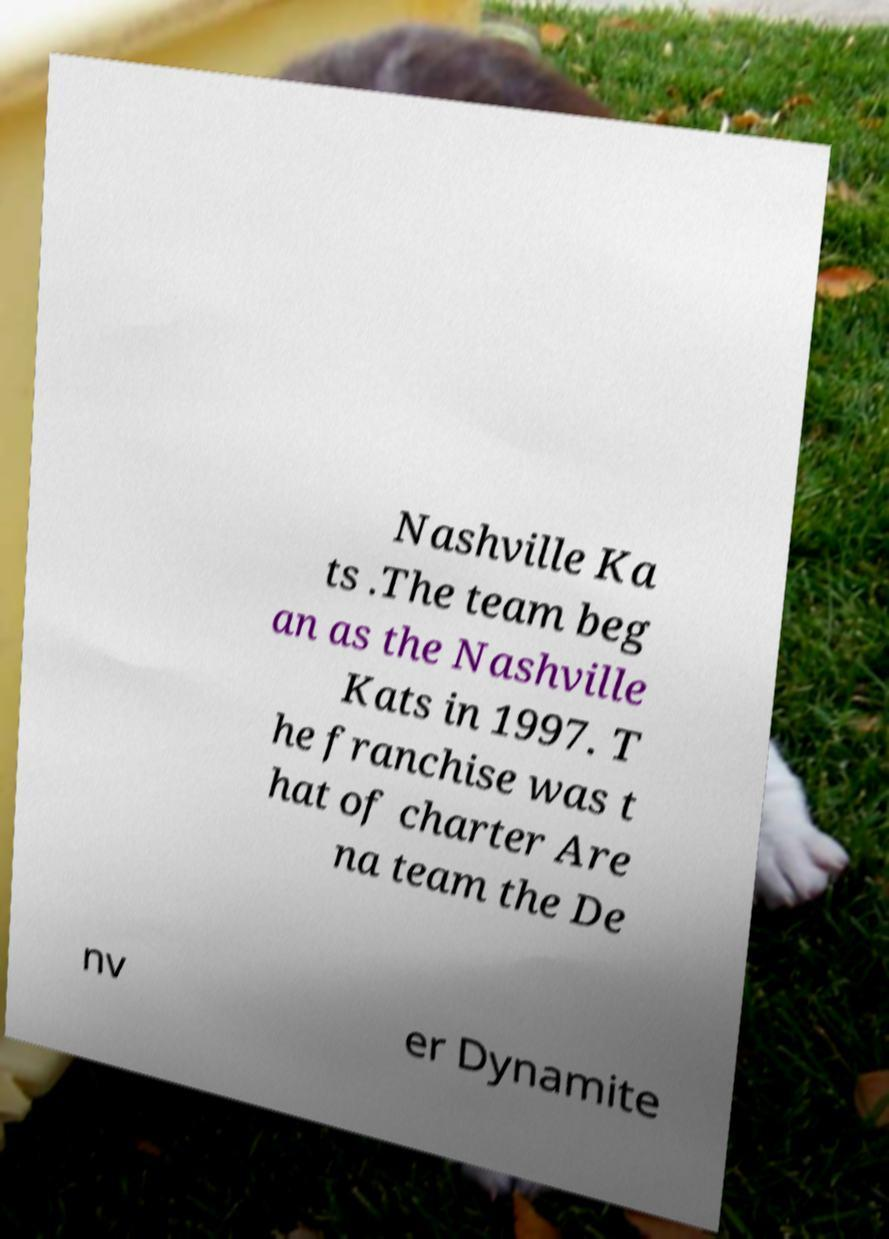For documentation purposes, I need the text within this image transcribed. Could you provide that? Nashville Ka ts .The team beg an as the Nashville Kats in 1997. T he franchise was t hat of charter Are na team the De nv er Dynamite 